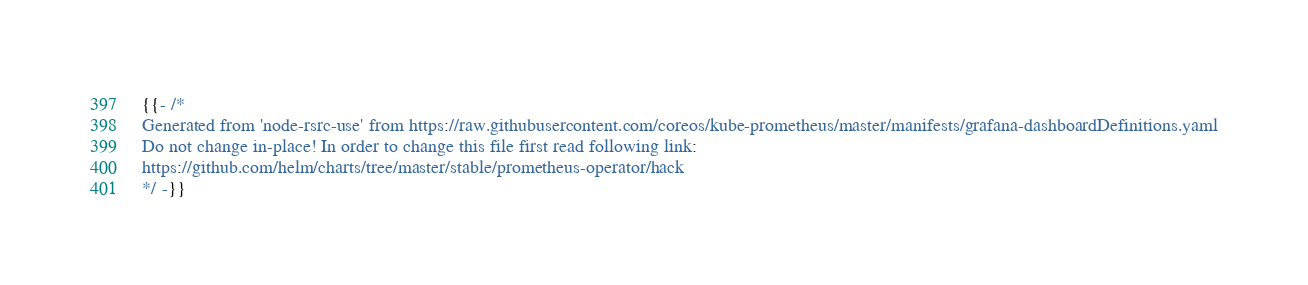Convert code to text. <code><loc_0><loc_0><loc_500><loc_500><_YAML_>{{- /*
Generated from 'node-rsrc-use' from https://raw.githubusercontent.com/coreos/kube-prometheus/master/manifests/grafana-dashboardDefinitions.yaml
Do not change in-place! In order to change this file first read following link:
https://github.com/helm/charts/tree/master/stable/prometheus-operator/hack
*/ -}}</code> 